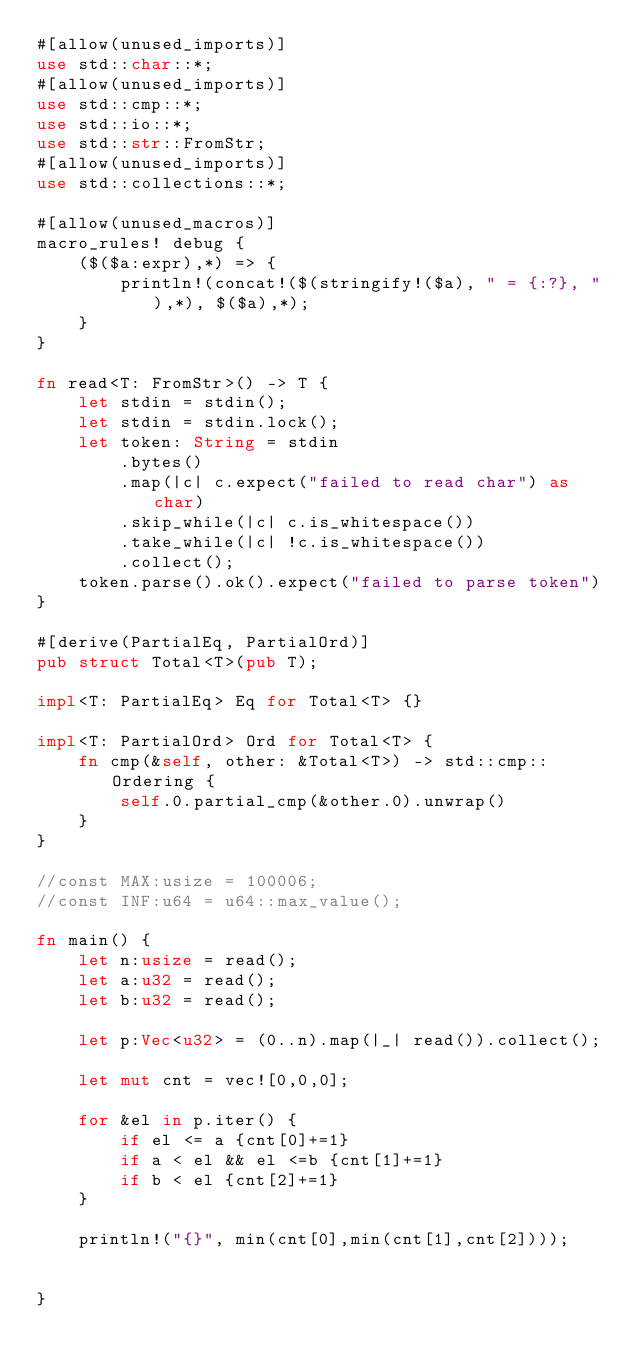<code> <loc_0><loc_0><loc_500><loc_500><_Rust_>#[allow(unused_imports)]
use std::char::*;
#[allow(unused_imports)]
use std::cmp::*;
use std::io::*;
use std::str::FromStr;
#[allow(unused_imports)]
use std::collections::*;

#[allow(unused_macros)]
macro_rules! debug {
    ($($a:expr),*) => {
        println!(concat!($(stringify!($a), " = {:?}, "),*), $($a),*);
    }
}

fn read<T: FromStr>() -> T {
    let stdin = stdin();
    let stdin = stdin.lock();
    let token: String = stdin
        .bytes()
        .map(|c| c.expect("failed to read char") as char)
        .skip_while(|c| c.is_whitespace())
        .take_while(|c| !c.is_whitespace())
        .collect();
    token.parse().ok().expect("failed to parse token")
}

#[derive(PartialEq, PartialOrd)]
pub struct Total<T>(pub T);

impl<T: PartialEq> Eq for Total<T> {}

impl<T: PartialOrd> Ord for Total<T> {
    fn cmp(&self, other: &Total<T>) -> std::cmp::Ordering {
        self.0.partial_cmp(&other.0).unwrap()
    }
}

//const MAX:usize = 100006;
//const INF:u64 = u64::max_value();

fn main() {
    let n:usize = read();
    let a:u32 = read();
    let b:u32 = read();

    let p:Vec<u32> = (0..n).map(|_| read()).collect();

    let mut cnt = vec![0,0,0];

    for &el in p.iter() {
        if el <= a {cnt[0]+=1}
        if a < el && el <=b {cnt[1]+=1}
        if b < el {cnt[2]+=1}
    }

    println!("{}", min(cnt[0],min(cnt[1],cnt[2])));


}
</code> 